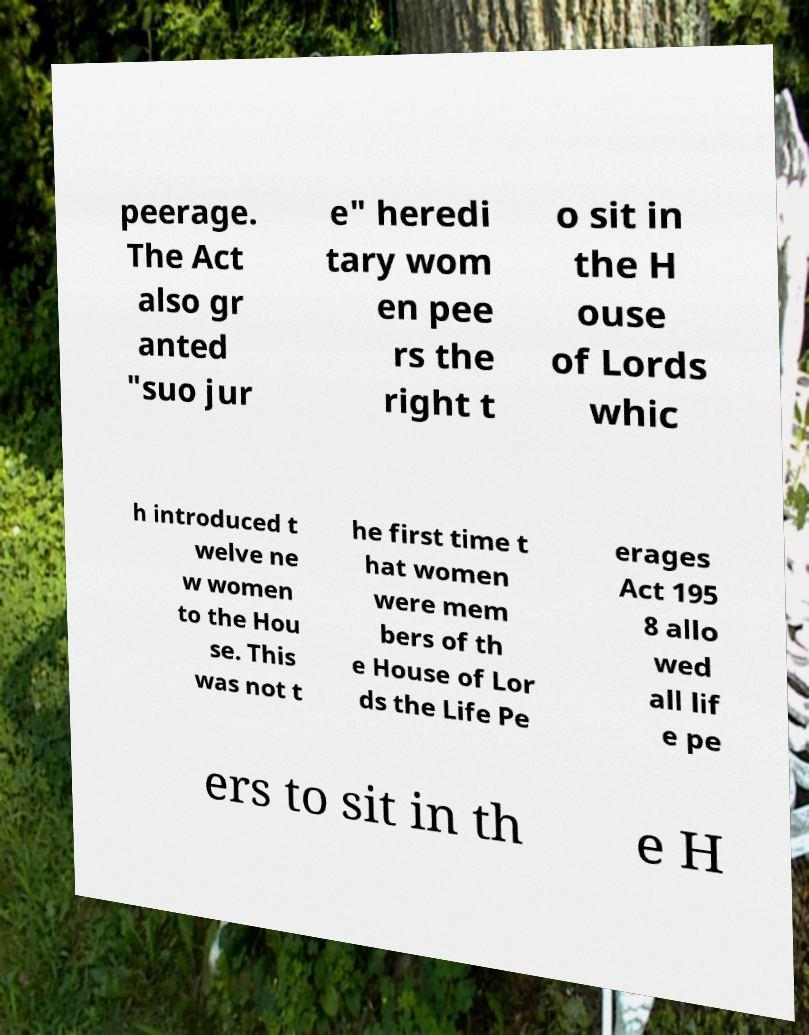There's text embedded in this image that I need extracted. Can you transcribe it verbatim? peerage. The Act also gr anted "suo jur e" heredi tary wom en pee rs the right t o sit in the H ouse of Lords whic h introduced t welve ne w women to the Hou se. This was not t he first time t hat women were mem bers of th e House of Lor ds the Life Pe erages Act 195 8 allo wed all lif e pe ers to sit in th e H 